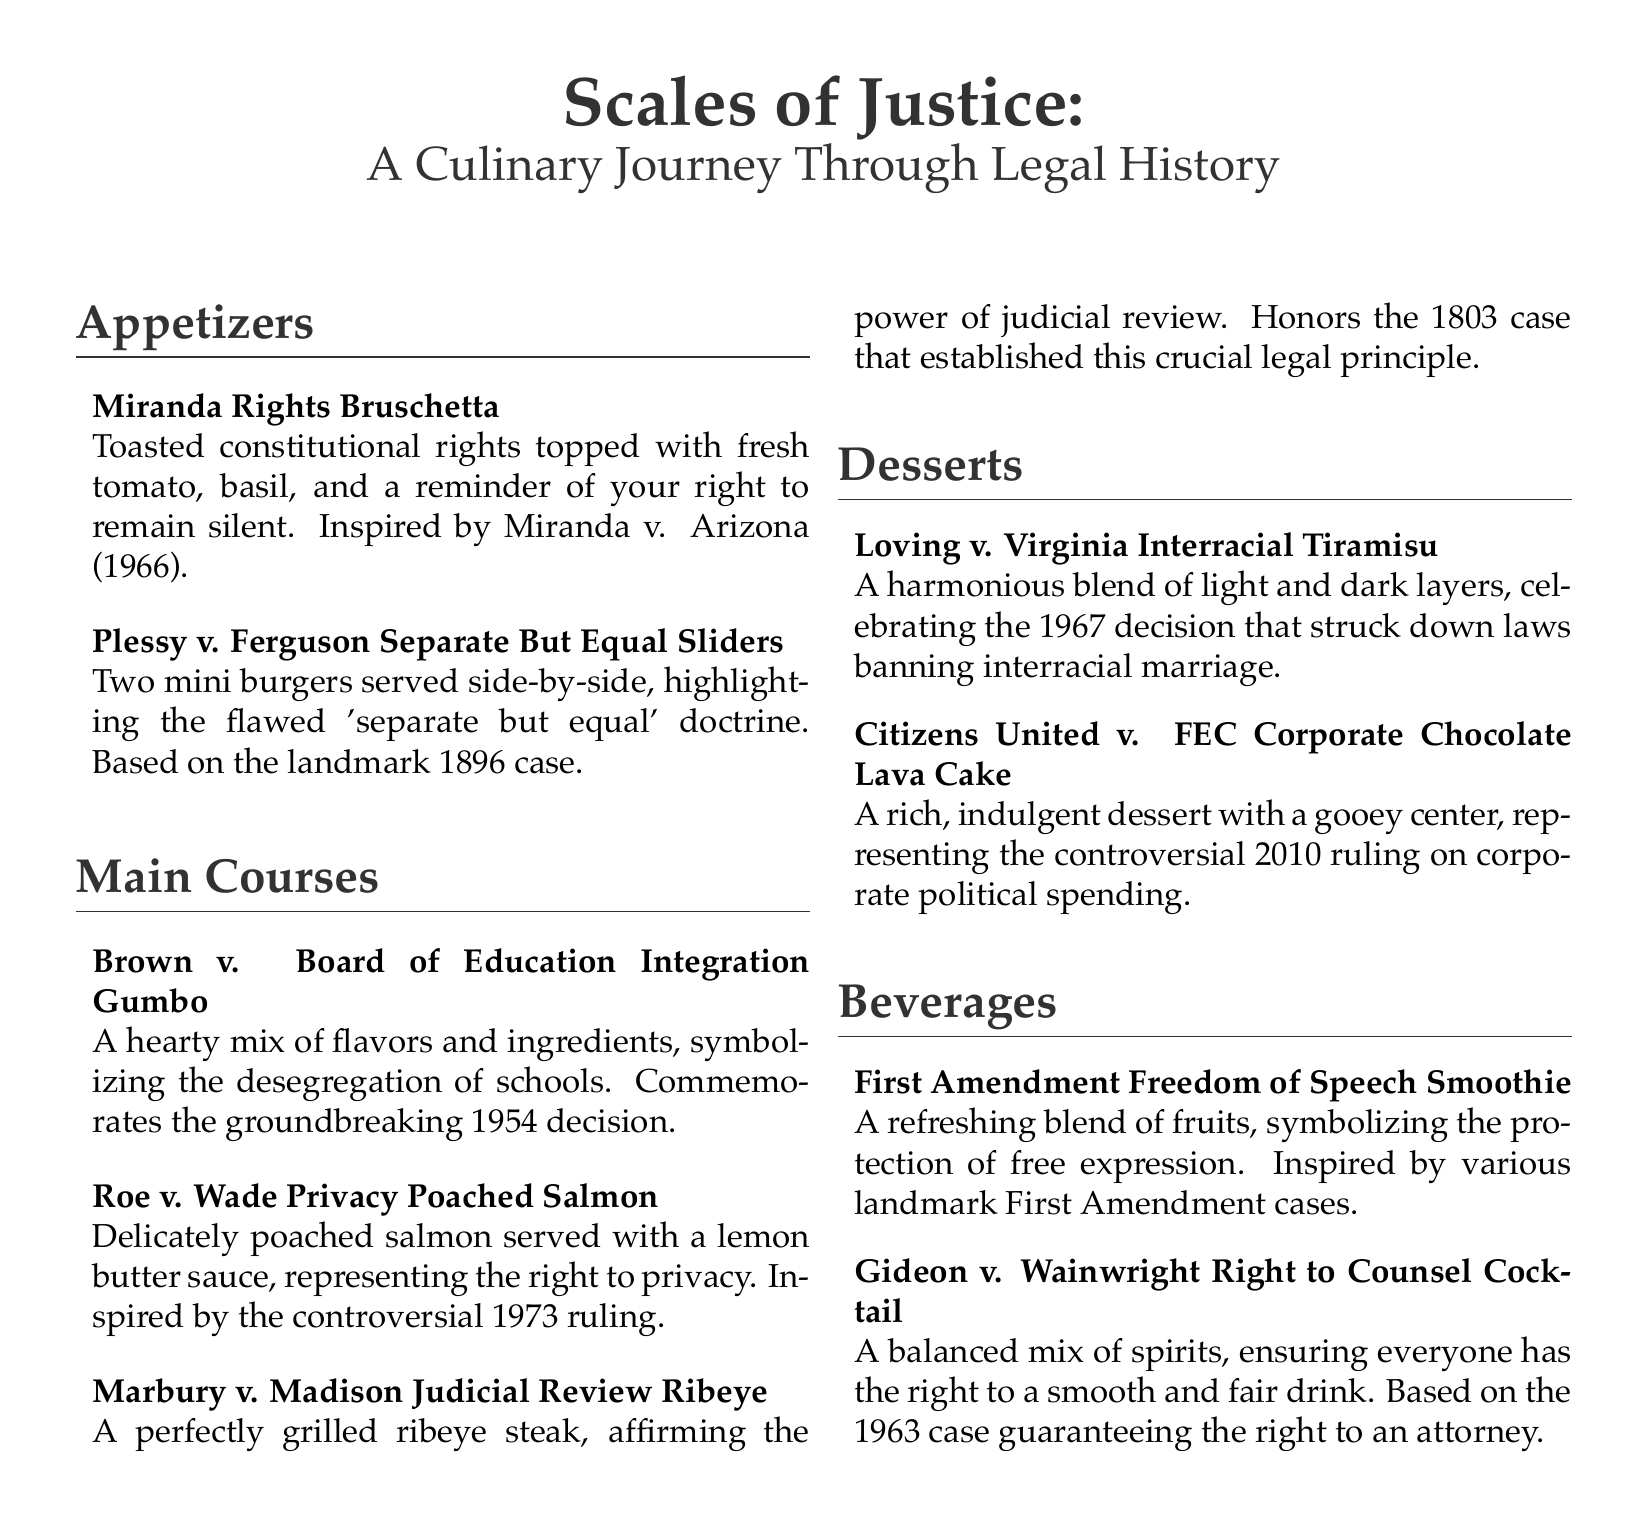What inspired the "Miranda Rights Bruschetta"? The "Miranda Rights Bruschetta" is inspired by the case Miranda v. Arizona (1966), which established the rights of individuals during police interrogations.
Answer: Miranda v. Arizona What type of dish is "Brown v. Board of Education Integration Gumbo"? "Brown v. Board of Education Integration Gumbo" is a main course dish that symbolizes the desegregation of schools.
Answer: Main course What year was "Loving v. Virginia" decided? The decision in "Loving v. Virginia," which struck down laws banning interracial marriage, was made in 1967.
Answer: 1967 How many appetizers are listed on the menu? There are two appetizers listed on the menu: "Miranda Rights Bruschetta" and "Plessy v. Ferguson Separate But Equal Sliders."
Answer: Two What does the "First Amendment Freedom of Speech Smoothie" represent? The "First Amendment Freedom of Speech Smoothie" represents the protection of free expression as inspired by various landmark First Amendment cases.
Answer: Free expression Which case inspired the "Roe v. Wade Privacy Poached Salmon"? The "Roe v. Wade Privacy Poached Salmon" is inspired by the controversial 1973 ruling regarding the right to privacy.
Answer: Roe v. Wade What dessert symbolizes corporate political spending? The "Citizens United v. FEC Corporate Chocolate Lava Cake" symbolizes corporate political spending as related to the 2010 ruling.
Answer: Citizens United v. FEC How is the "Gideon v. Wainwright Right to Counsel Cocktail" described? The "Gideon v. Wainwright Right to Counsel Cocktail" is described as a balanced mix of spirits, ensuring everyone has the right to a smooth and fair drink.
Answer: Balanced mix of spirits What is the main theme of the restaurant menu? The main theme of the restaurant menu is a culinary journey through legal history, showcasing dishes inspired by famous court cases.
Answer: Culinary journey through legal history 